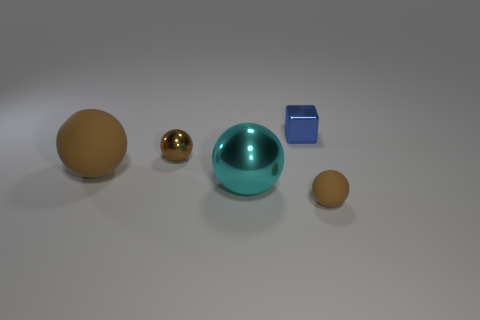Is there a metallic sphere of the same color as the large rubber ball?
Your answer should be very brief. Yes. The metal object that is the same color as the small matte ball is what size?
Give a very brief answer. Small. What shape is the small rubber thing that is the same color as the tiny shiny ball?
Make the answer very short. Sphere. Are there any other things that have the same color as the large matte sphere?
Your response must be concise. Yes. Does the small metal ball have the same color as the rubber sphere to the right of the tiny brown shiny object?
Make the answer very short. Yes. What number of objects are balls behind the tiny brown rubber ball or tiny brown spheres that are in front of the brown metal ball?
Make the answer very short. 4. Are there more balls behind the tiny blue thing than tiny cubes on the left side of the big brown thing?
Ensure brevity in your answer.  No. There is a brown ball in front of the brown rubber ball behind the object that is on the right side of the blue metal thing; what is it made of?
Make the answer very short. Rubber. Do the matte object on the left side of the cyan metallic thing and the tiny brown matte thing in front of the blue thing have the same shape?
Offer a terse response. Yes. Is there a shiny ball that has the same size as the blue cube?
Provide a short and direct response. Yes. 